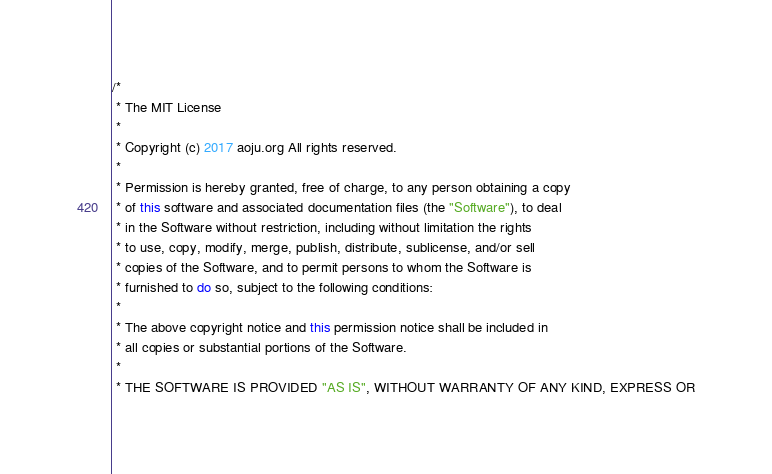Convert code to text. <code><loc_0><loc_0><loc_500><loc_500><_Java_>/*
 * The MIT License
 *
 * Copyright (c) 2017 aoju.org All rights reserved.
 *
 * Permission is hereby granted, free of charge, to any person obtaining a copy
 * of this software and associated documentation files (the "Software"), to deal
 * in the Software without restriction, including without limitation the rights
 * to use, copy, modify, merge, publish, distribute, sublicense, and/or sell
 * copies of the Software, and to permit persons to whom the Software is
 * furnished to do so, subject to the following conditions:
 *
 * The above copyright notice and this permission notice shall be included in
 * all copies or substantial portions of the Software.
 *
 * THE SOFTWARE IS PROVIDED "AS IS", WITHOUT WARRANTY OF ANY KIND, EXPRESS OR</code> 